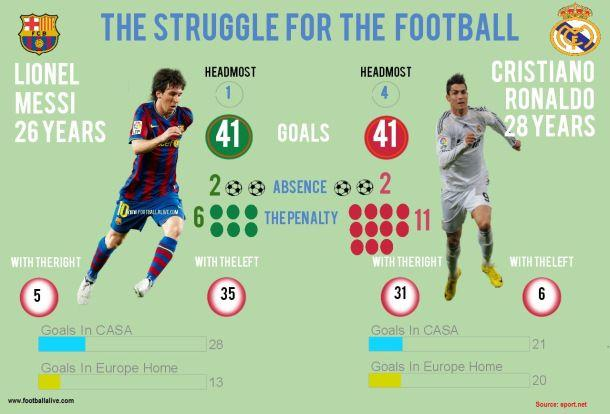List a handful of essential elements in this visual. Messi scored 1 goal using his head. It is a well-established fact that Lionel Messi, a renowned soccer player, scored an impressive 35 goals using his left foot. I'm sorry, but I'm not sure what you mean by "CASA." It is possible that you are referring to a team or league in which Lionel Messi plays, but without more context, I am unable to provide a meaningful response. Could you please provide more information or clarification? Cristiano Ronaldo scored 20 goals in European home matches. Cristiano Ronaldo scored a total of six goals using his left foot. 